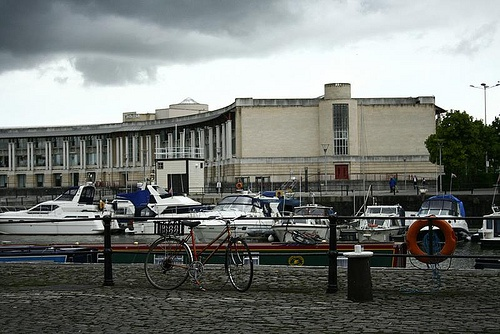Describe the objects in this image and their specific colors. I can see bicycle in blue, black, gray, and darkgray tones, boat in blue, black, darkgray, gray, and lightgray tones, boat in blue, lightgray, black, gray, and darkgray tones, boat in blue, black, gray, darkgray, and lightgray tones, and boat in blue, black, gray, darkgray, and lightgray tones in this image. 